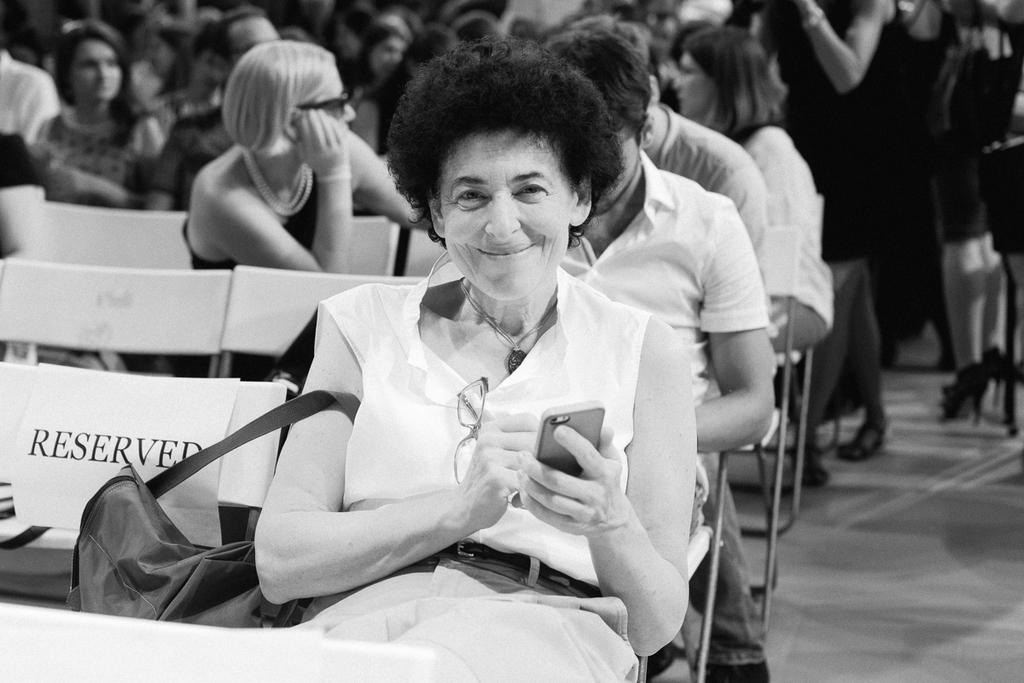What is the general composition of the people in the image? There is a group of people in the image, with some sitting and others standing. Can you describe a specific person in the image? There is a woman with a white shirt in the image, and she is sitting and smiling. What is the woman holding in her hand? The woman is holding a phone in her left hand. What type of branch is being used to pump water in the image? There is no branch or pump present in the image; it features a group of people with a woman holding a phone. 